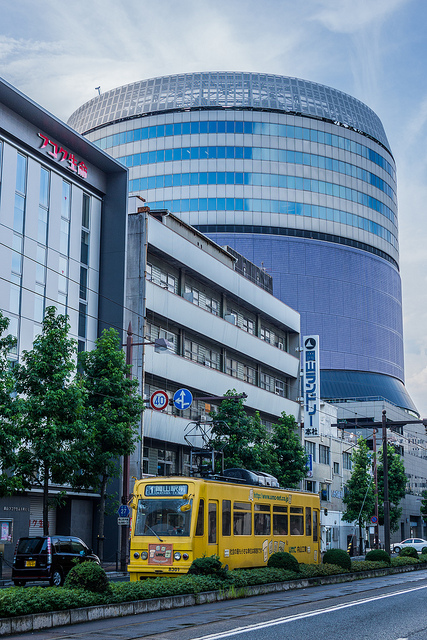Please transcribe the text information in this image. 40 